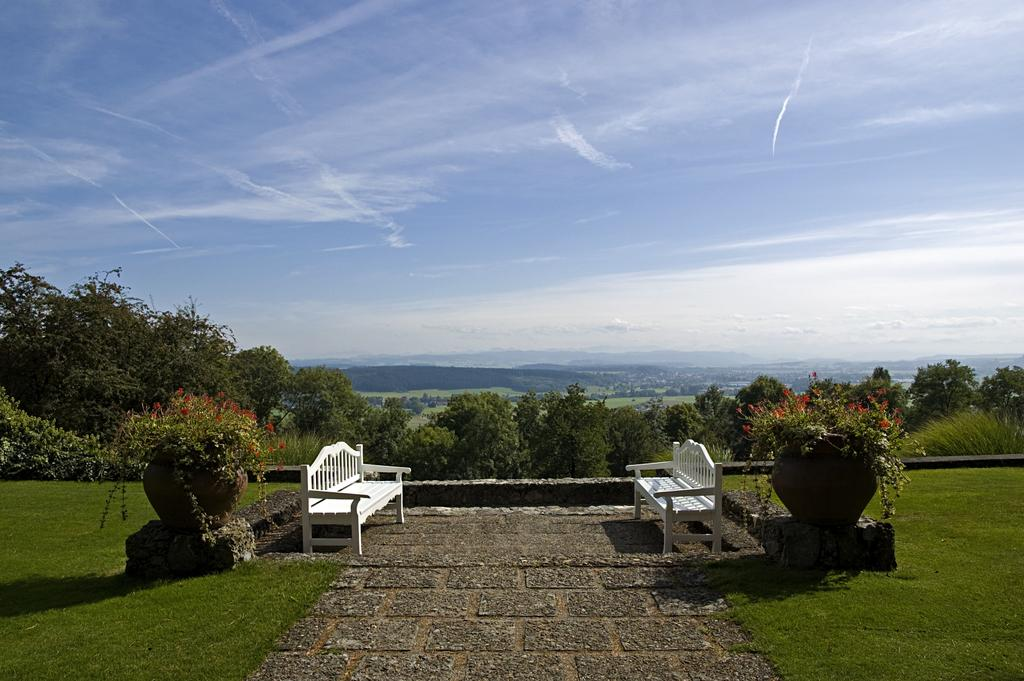How many benches are present in the image? There are two benches in the image. What other objects can be seen in the image? There are two flower pots in the image. What type of vegetation is visible in the image? There are trees in the image. What is the color of the sky in the image? The sky is blue in the image. Are there any worms crawling on the benches in the image? There is no mention of worms in the image, so we cannot determine if any are present. What type of mask is being worn by the trees in the image? There are no masks present in the image, as it features trees and benches. 